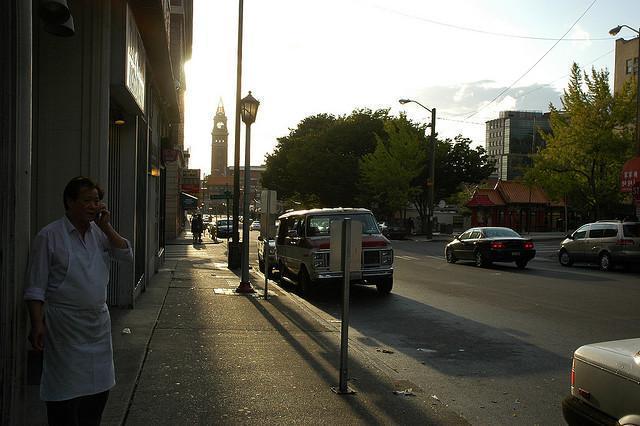How many vans are pictured?
Give a very brief answer. 1. How many cars are there?
Give a very brief answer. 3. 